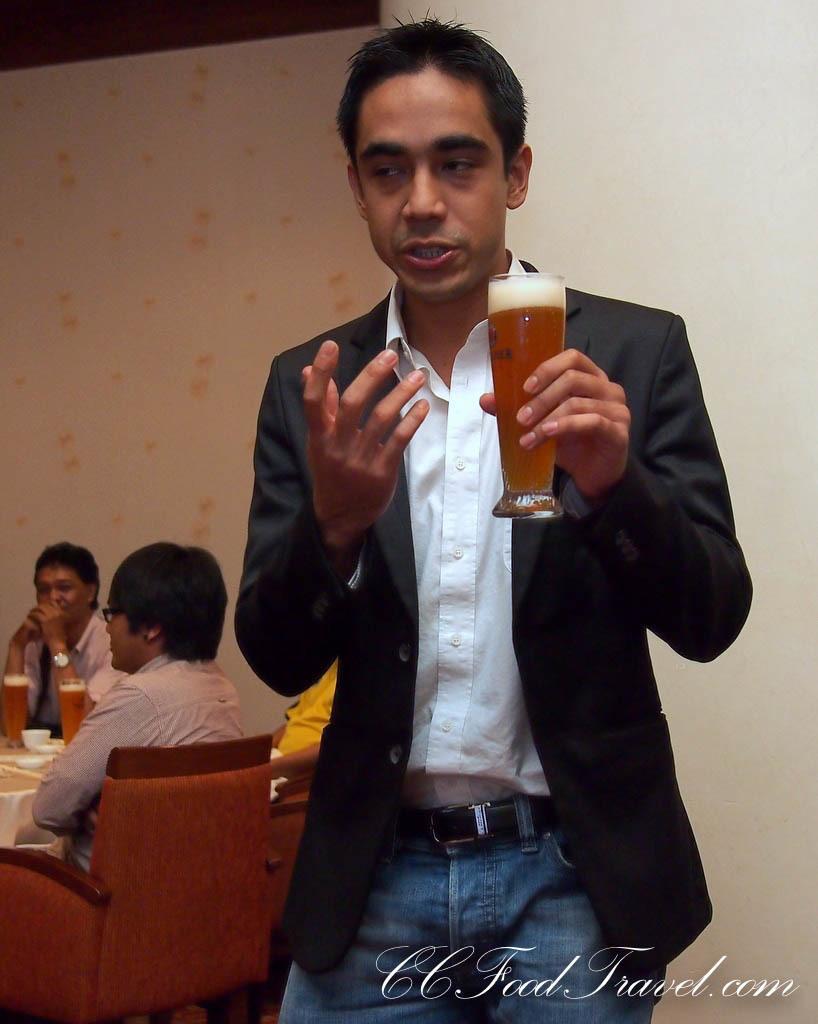Describe this image in one or two sentences. In this picture we can see man wore blazer holding glass in his hand and in the background we can see three people sitting on chair and in front of them we have table and on table we can see cup, glasses and here is wall. 